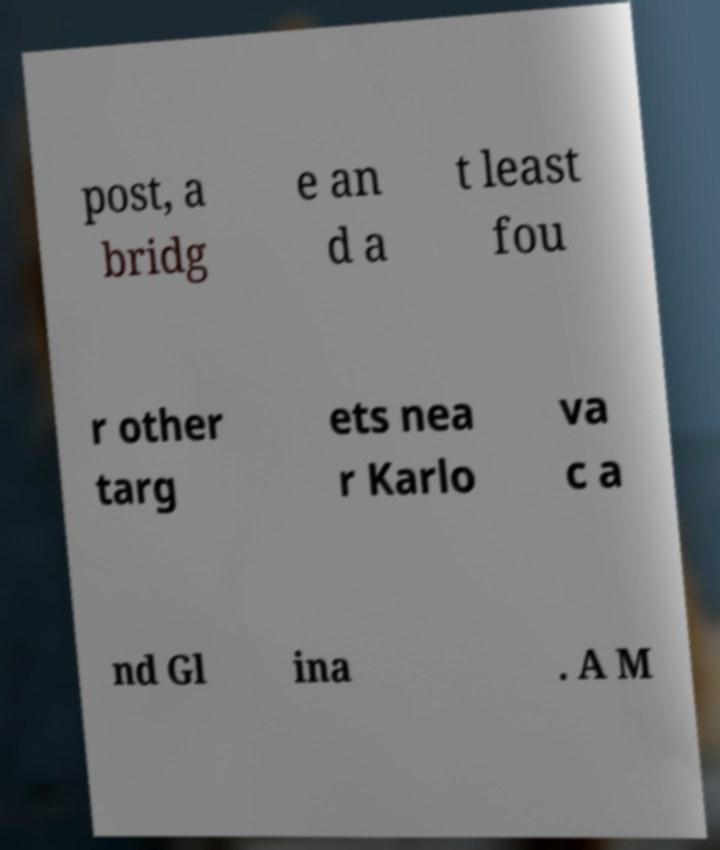Can you accurately transcribe the text from the provided image for me? post, a bridg e an d a t least fou r other targ ets nea r Karlo va c a nd Gl ina . A M 